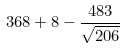Convert formula to latex. <formula><loc_0><loc_0><loc_500><loc_500>3 6 8 + 8 - \frac { 4 8 3 } { \sqrt { 2 0 6 } }</formula> 